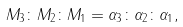<formula> <loc_0><loc_0><loc_500><loc_500>M _ { 3 } \colon M _ { 2 } \colon M _ { 1 } = \alpha _ { 3 } \colon \alpha _ { 2 } \colon \alpha _ { 1 } ,</formula> 